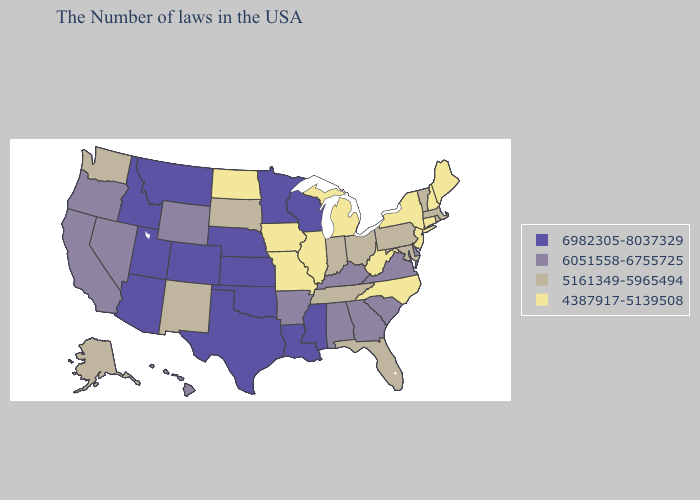Does the first symbol in the legend represent the smallest category?
Be succinct. No. Does the map have missing data?
Be succinct. No. What is the highest value in states that border Oklahoma?
Be succinct. 6982305-8037329. Name the states that have a value in the range 6982305-8037329?
Write a very short answer. Wisconsin, Mississippi, Louisiana, Minnesota, Kansas, Nebraska, Oklahoma, Texas, Colorado, Utah, Montana, Arizona, Idaho. Name the states that have a value in the range 6982305-8037329?
Short answer required. Wisconsin, Mississippi, Louisiana, Minnesota, Kansas, Nebraska, Oklahoma, Texas, Colorado, Utah, Montana, Arizona, Idaho. What is the highest value in states that border Ohio?
Be succinct. 6051558-6755725. Name the states that have a value in the range 6051558-6755725?
Give a very brief answer. Delaware, Virginia, South Carolina, Georgia, Kentucky, Alabama, Arkansas, Wyoming, Nevada, California, Oregon, Hawaii. Name the states that have a value in the range 4387917-5139508?
Quick response, please. Maine, New Hampshire, Connecticut, New York, New Jersey, North Carolina, West Virginia, Michigan, Illinois, Missouri, Iowa, North Dakota. Among the states that border Oregon , which have the highest value?
Short answer required. Idaho. What is the value of Rhode Island?
Be succinct. 5161349-5965494. Does Pennsylvania have the highest value in the USA?
Answer briefly. No. Does the first symbol in the legend represent the smallest category?
Quick response, please. No. What is the lowest value in the Northeast?
Quick response, please. 4387917-5139508. Name the states that have a value in the range 6051558-6755725?
Be succinct. Delaware, Virginia, South Carolina, Georgia, Kentucky, Alabama, Arkansas, Wyoming, Nevada, California, Oregon, Hawaii. 